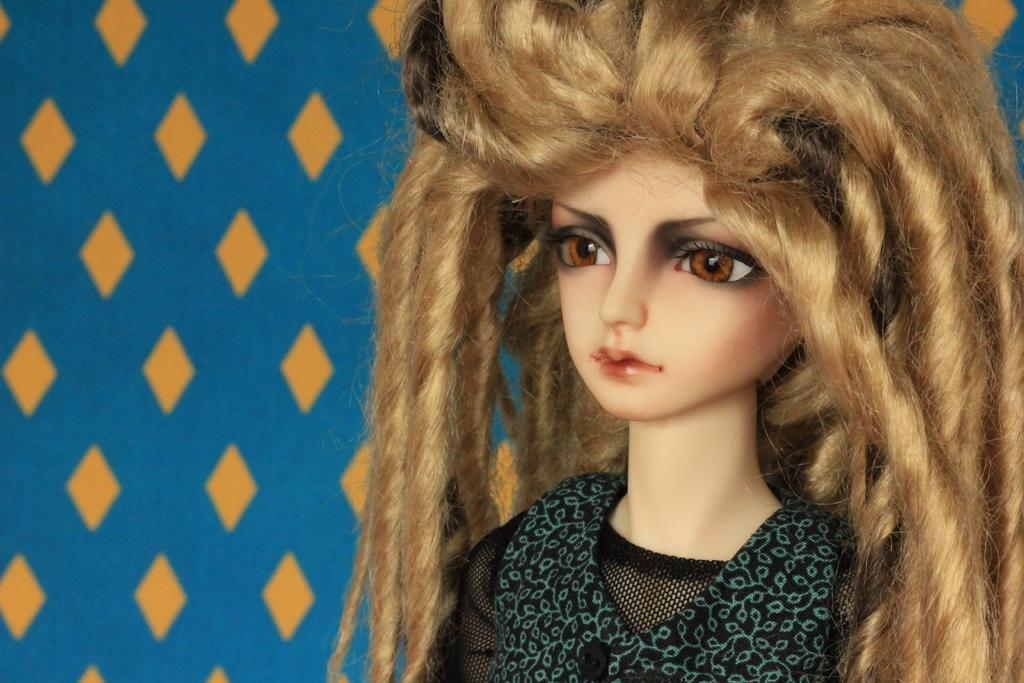What is the main subject in the image? There is a doll in the image. Can you describe the background or setting of the image? There is a designed wall in the image. How many giants can be seen interacting with the doll in the image? There are no giants present in the image. 